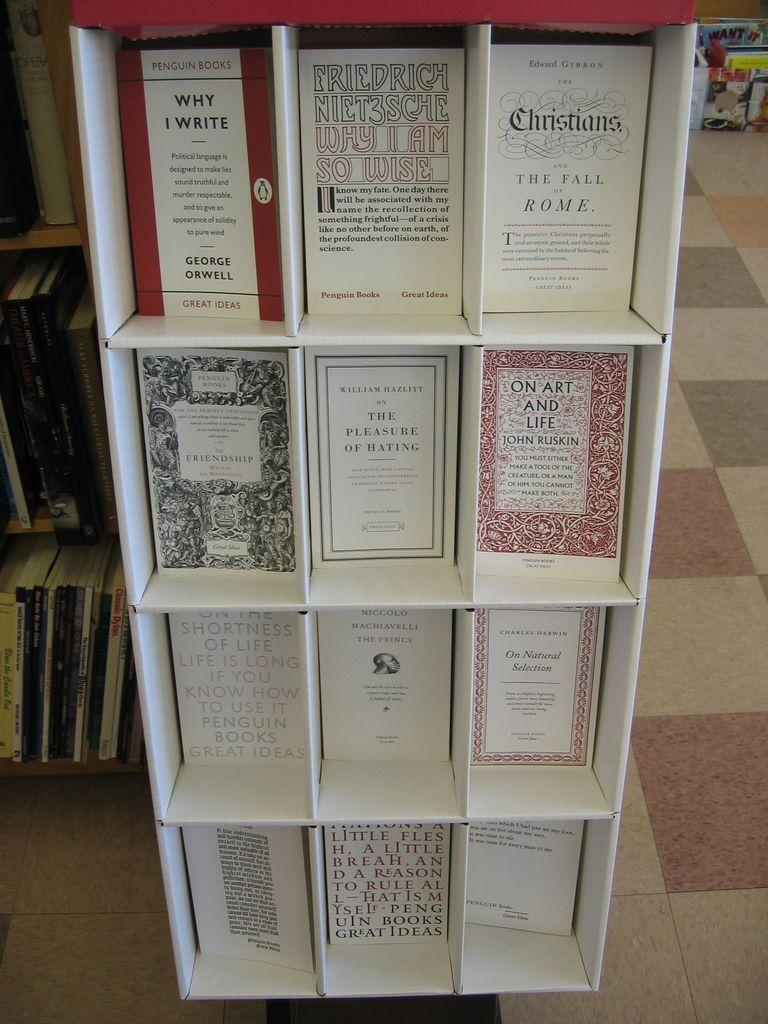<image>
Render a clear and concise summary of the photo. Several books sit in a bookstore display including titles such as Christians and The Fall of Rome. 